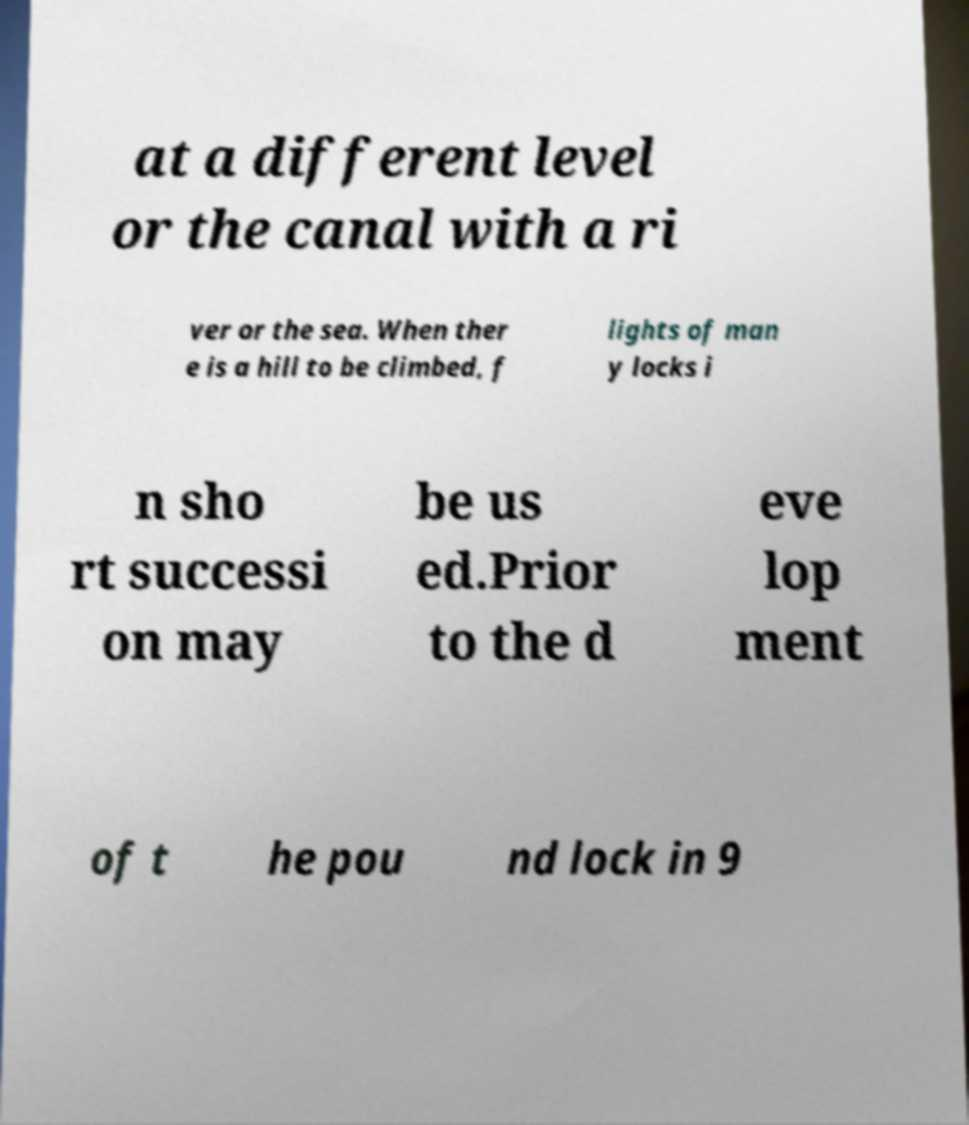Could you assist in decoding the text presented in this image and type it out clearly? at a different level or the canal with a ri ver or the sea. When ther e is a hill to be climbed, f lights of man y locks i n sho rt successi on may be us ed.Prior to the d eve lop ment of t he pou nd lock in 9 